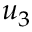Convert formula to latex. <formula><loc_0><loc_0><loc_500><loc_500>u _ { 3 }</formula> 